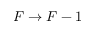Convert formula to latex. <formula><loc_0><loc_0><loc_500><loc_500>F \rightarrow F - 1</formula> 